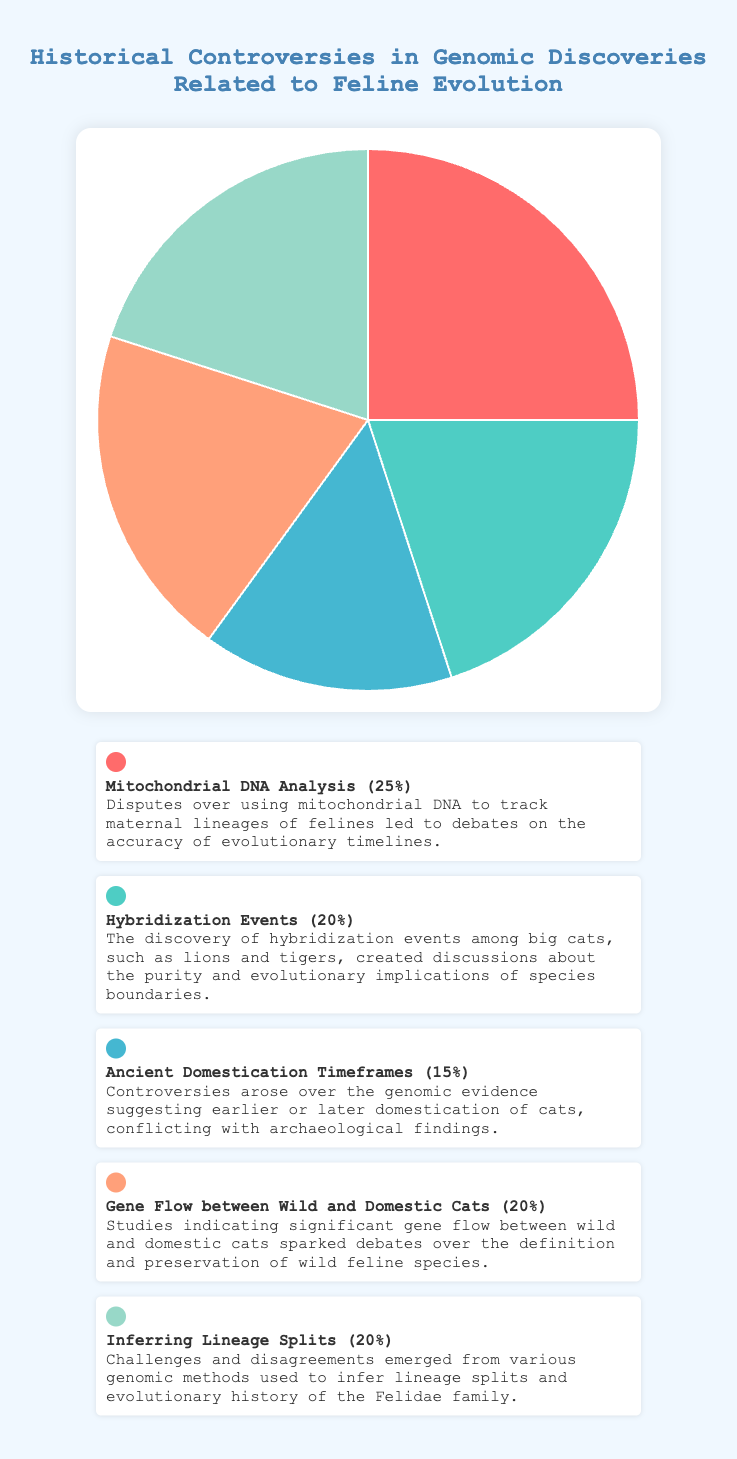What's the controversy with the highest percentage? The highest percentage segment in the chart is "Mitochondrial DNA Analysis" at 25%.
Answer: Mitochondrial DNA Analysis Which controversies have equal percentages? The chart shows "Hybridization Events," "Gene Flow between Wild and Domestic Cats," and "Inferring Lineage Splits" each with 20%.
Answer: Hybridization Events, Gene Flow between Wild and Domestic Cats, Inferring Lineage Splits What is the combined percentage of "Hybridization Events" and "Gene Flow between Wild and Domestic Cats"? Adding the percentages of "Hybridization Events (20%)" and "Gene Flow between Wild and Domestic Cats (20%)" gives 20% + 20% = 40%.
Answer: 40% Which color represents the controversy related to "Ancient Domestication Timeframes"? The color used for "Ancient Domestication Timeframes" is represented by a light blue shade.
Answer: Light blue If "Inferring Lineage Splits" and "Mitochondrial DNA Analysis" comprise of the same percentage, by how much does "Mitochondrial DNA Analysis" exceed the next largest category? Both "Inferring Lineage Splits" and "Gene Flow between Wild and Domestic Cats" have 20%, which means "Mitochondrial DNA Analysis" (25%) exceeds these by 25% - 20% = 5%.
Answer: 5% 